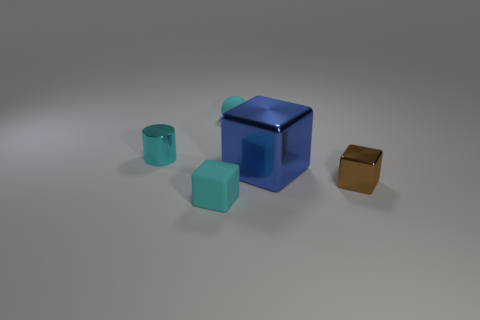What could the purpose of these objects be, and do they suggest any specific setting or theme? The objects' simplicity and the clean, unadorned surface they rest upon give the scene an abstract quality. The differing geometric shapes and the polished surfaces might suggest that we're looking at a minimalist art installation, where the interplay of shapes, colors, and materials invites contemplation. Alternatively, these could be conceptual representations of elements in a design project, emphasizing form and color over function.  Is there anything about the lighting or shadows that tells us more about the environment? The lighting in the image is soft and diffused, casting gentle shadows that anchor the objects to the surface without harsh contrasts. This even light suggests an indoor setting, possibly a studio where objects are intentionally staged for visual effect. The shadows elongate slightly towards the bottom, indicating the light source is located above and potentially somewhat in front of the objects. 